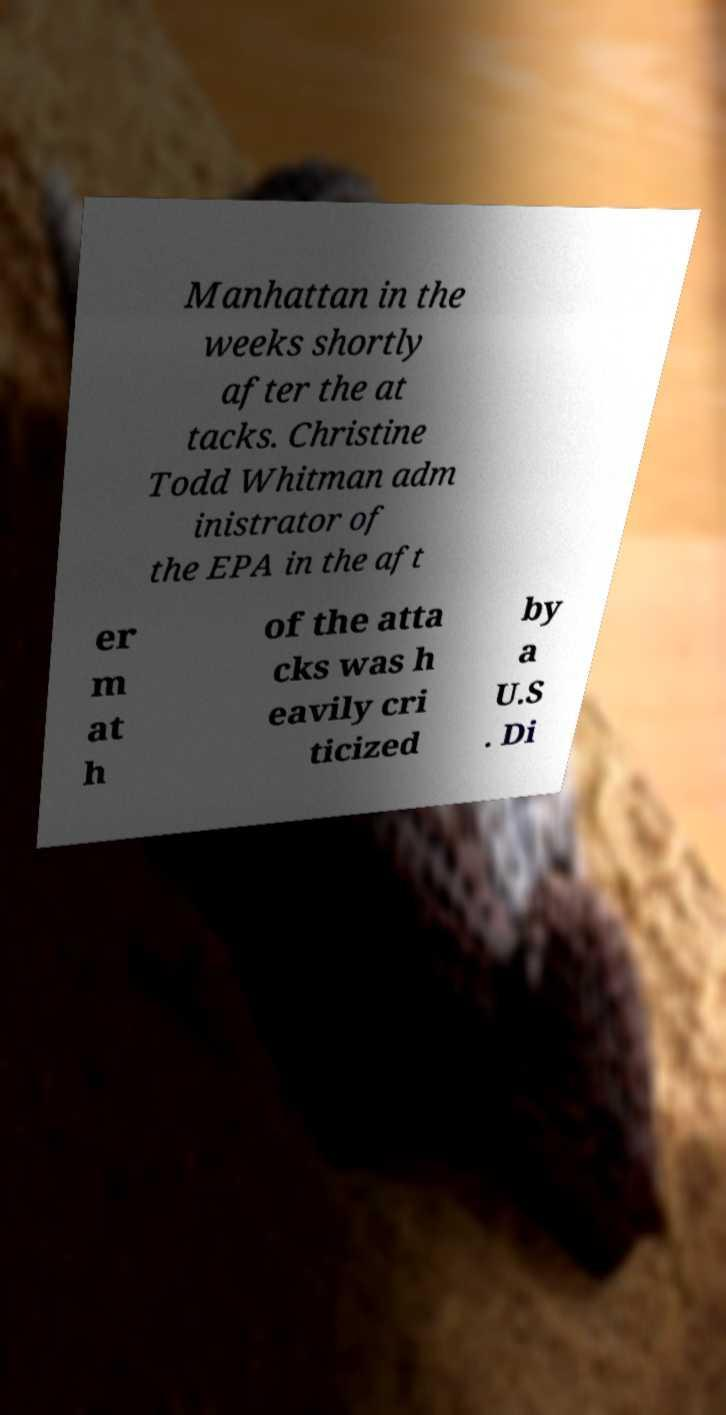There's text embedded in this image that I need extracted. Can you transcribe it verbatim? Manhattan in the weeks shortly after the at tacks. Christine Todd Whitman adm inistrator of the EPA in the aft er m at h of the atta cks was h eavily cri ticized by a U.S . Di 